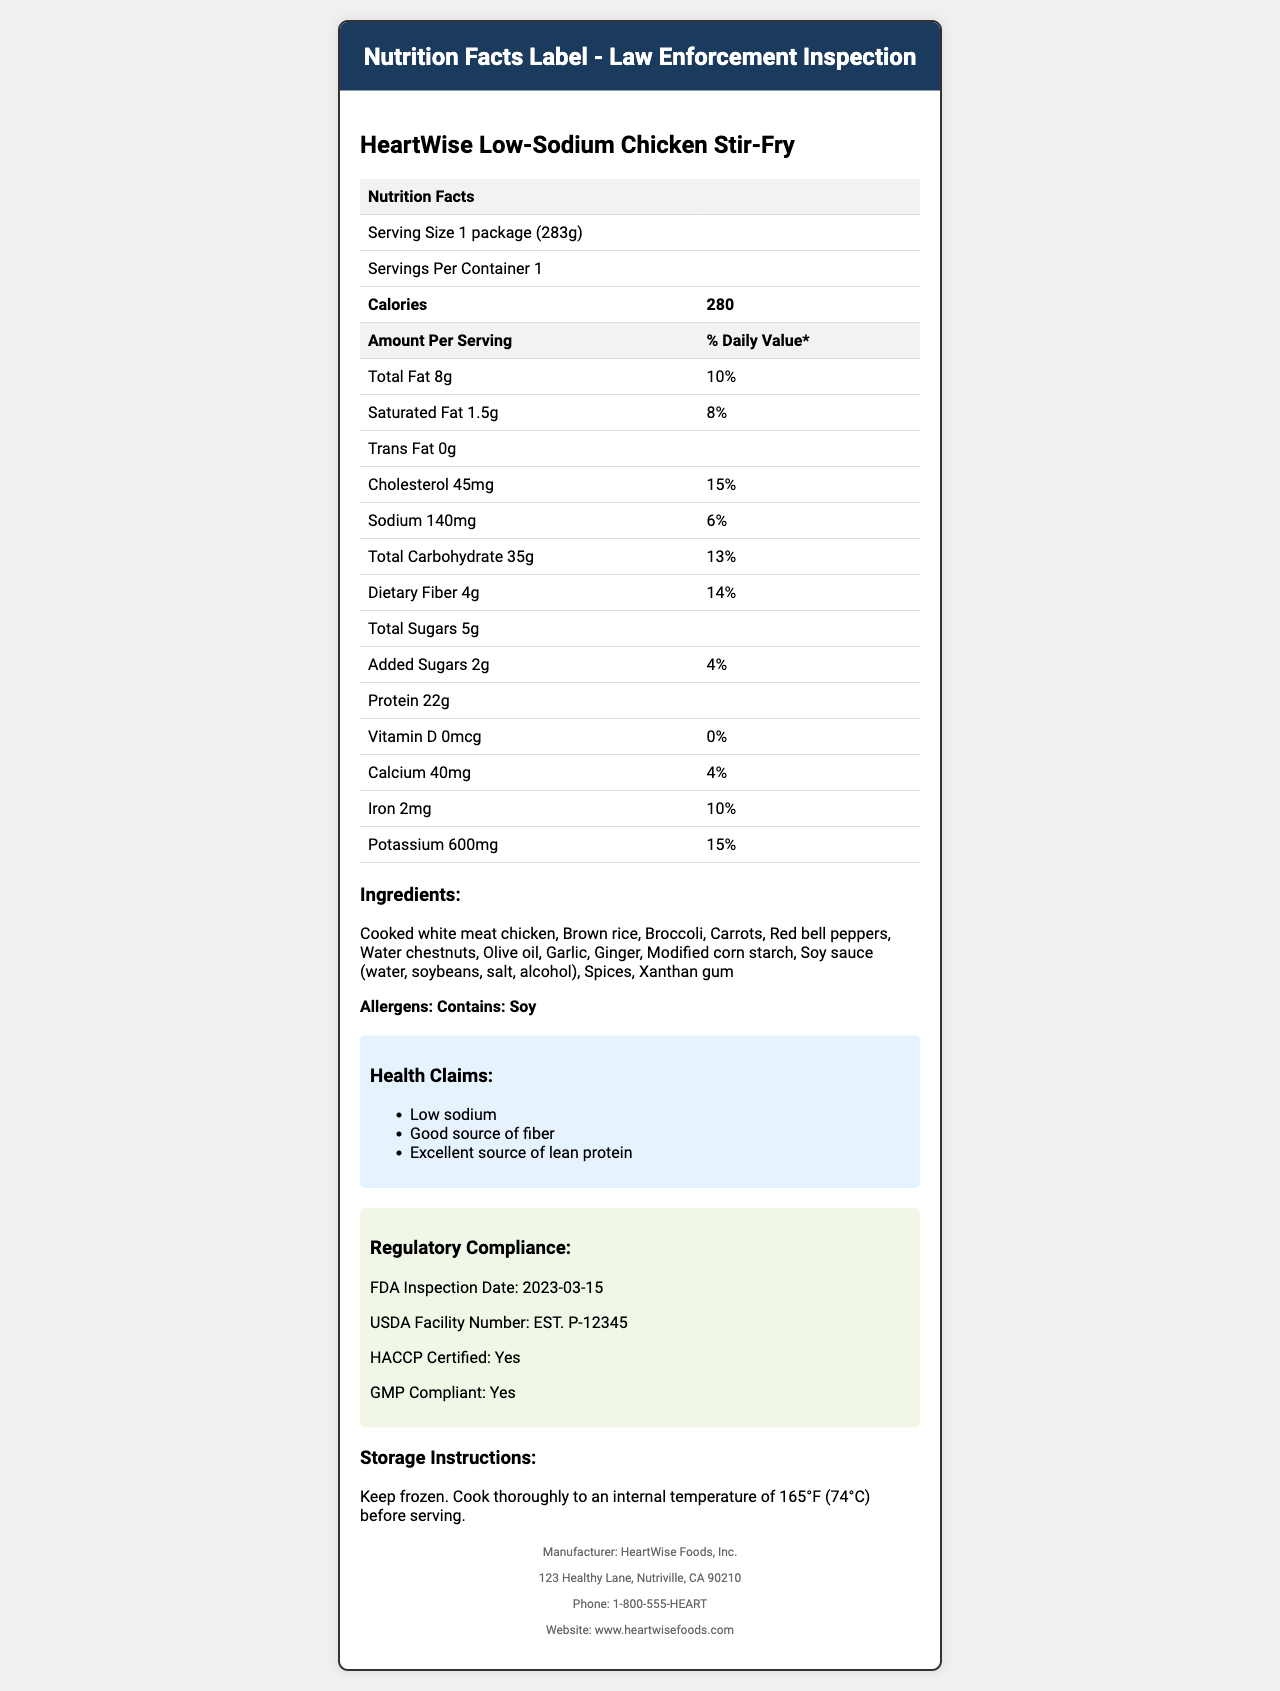what is the serving size? The serving size is provided at the beginning of the nutrition facts section of the document.
Answer: 1 package (283g) how many calories are in one serving? The calories amount per serving is listed in the bold row under the nutrition facts section.
Answer: 280 what is the total fat content in one serving? The total fat content is listed under the Amount Per Serving column in the nutrition facts table.
Answer: 8g how much sodium does this product contain per serving? The sodium content is listed in the Amount Per Serving column in the nutrition facts table.
Answer: 140mg name one ingredient in the HeartWise Low-Sodium Chicken Stir-Fry. The list of ingredients is provided under the Ingredients section of the document.
Answer: Broccoli which of the following is true about the packaging? A. Contains BPA B. Not recyclable C. Tamper-evident seal D. Not GMP compliant The packaging information section indicates the product is BPA-free, recyclable, and has a tamper-evident seal.
Answer: C how much protein is in one serving? A. 15g B. 22g C. 28g D. 10g The protein content per serving is listed as 22g in the nutrition facts table.
Answer: B is the product HACCP certified? The regulatory compliance section states that the product is HACCP certified.
Answer: Yes summary of the entire document The document includes nutrition information, an ingredients list, certifications, health claims, packaging, and manufacturer information.
Answer: HeartWise Low-Sodium Chicken Stir-Fry is a low-sodium frozen meal targeted at heart health-conscious consumers. It includes a detailed nutrition facts label, a list of ingredients, allergens information, health claims, regulatory compliance certifications, storage instructions, and manufacturer contact details. what is the facility number of the USDA inspected facility? In the regulatory compliance section, the USDA Facility Number is listed as EST. P-12345.
Answer: EST. P-12345 what is the date of the most recent FDA inspection? The FDA inspection date is noted as 2023-03-15 in the regulatory compliance section.
Answer: 2023-03-15 are there any added sugars in this product? The nutrition facts chart lists added sugars and provides the amount of 2g.
Answer: Yes what is the main allergen present in this product? The allergens section specifies the product contains soy.
Answer: Soy for what audience is this product mainly targeted? The low-sodium content and specifying heart health-conscious consumers indicate the target audience.
Answer: Heart health-conscious consumers how to store this product? The storage instructions provide specific details on storing and cooking the product.
Answer: Keep frozen. Cook thoroughly to an internal temperature of 165°F (74°C) before serving. is this product suitable for vegetarians? The document does not provide enough information to determine if all ingredients meet vegetarian standards.
Answer: Cannot be determined which claim is made about the fiber content? One of the health claims listed is "Good source of fiber".
Answer: Good source of fiber 